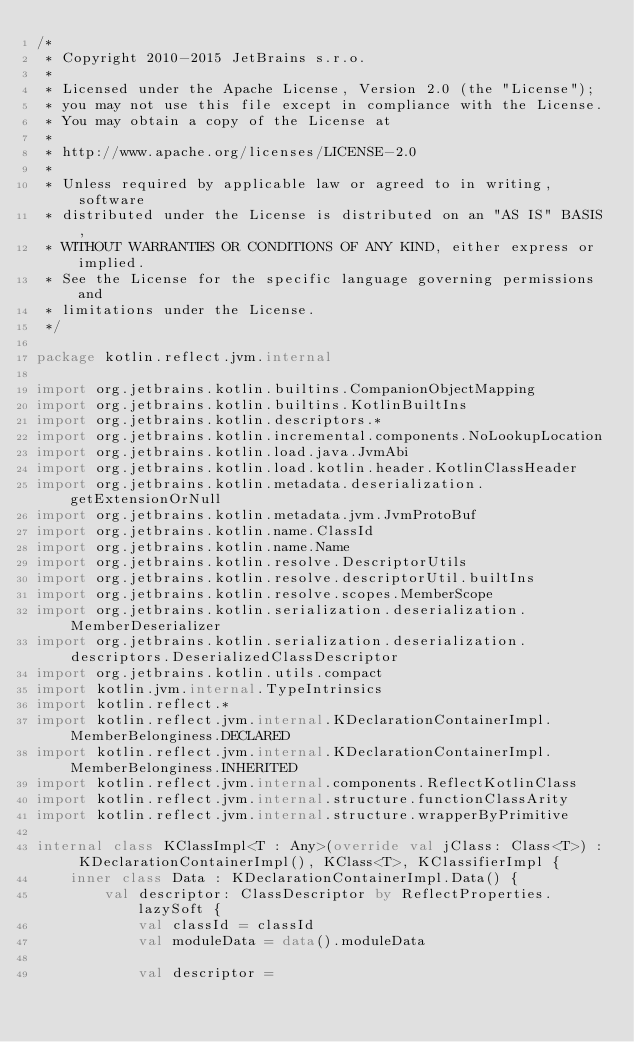<code> <loc_0><loc_0><loc_500><loc_500><_Kotlin_>/*
 * Copyright 2010-2015 JetBrains s.r.o.
 *
 * Licensed under the Apache License, Version 2.0 (the "License");
 * you may not use this file except in compliance with the License.
 * You may obtain a copy of the License at
 *
 * http://www.apache.org/licenses/LICENSE-2.0
 *
 * Unless required by applicable law or agreed to in writing, software
 * distributed under the License is distributed on an "AS IS" BASIS,
 * WITHOUT WARRANTIES OR CONDITIONS OF ANY KIND, either express or implied.
 * See the License for the specific language governing permissions and
 * limitations under the License.
 */

package kotlin.reflect.jvm.internal

import org.jetbrains.kotlin.builtins.CompanionObjectMapping
import org.jetbrains.kotlin.builtins.KotlinBuiltIns
import org.jetbrains.kotlin.descriptors.*
import org.jetbrains.kotlin.incremental.components.NoLookupLocation
import org.jetbrains.kotlin.load.java.JvmAbi
import org.jetbrains.kotlin.load.kotlin.header.KotlinClassHeader
import org.jetbrains.kotlin.metadata.deserialization.getExtensionOrNull
import org.jetbrains.kotlin.metadata.jvm.JvmProtoBuf
import org.jetbrains.kotlin.name.ClassId
import org.jetbrains.kotlin.name.Name
import org.jetbrains.kotlin.resolve.DescriptorUtils
import org.jetbrains.kotlin.resolve.descriptorUtil.builtIns
import org.jetbrains.kotlin.resolve.scopes.MemberScope
import org.jetbrains.kotlin.serialization.deserialization.MemberDeserializer
import org.jetbrains.kotlin.serialization.deserialization.descriptors.DeserializedClassDescriptor
import org.jetbrains.kotlin.utils.compact
import kotlin.jvm.internal.TypeIntrinsics
import kotlin.reflect.*
import kotlin.reflect.jvm.internal.KDeclarationContainerImpl.MemberBelonginess.DECLARED
import kotlin.reflect.jvm.internal.KDeclarationContainerImpl.MemberBelonginess.INHERITED
import kotlin.reflect.jvm.internal.components.ReflectKotlinClass
import kotlin.reflect.jvm.internal.structure.functionClassArity
import kotlin.reflect.jvm.internal.structure.wrapperByPrimitive

internal class KClassImpl<T : Any>(override val jClass: Class<T>) : KDeclarationContainerImpl(), KClass<T>, KClassifierImpl {
    inner class Data : KDeclarationContainerImpl.Data() {
        val descriptor: ClassDescriptor by ReflectProperties.lazySoft {
            val classId = classId
            val moduleData = data().moduleData

            val descriptor =</code> 